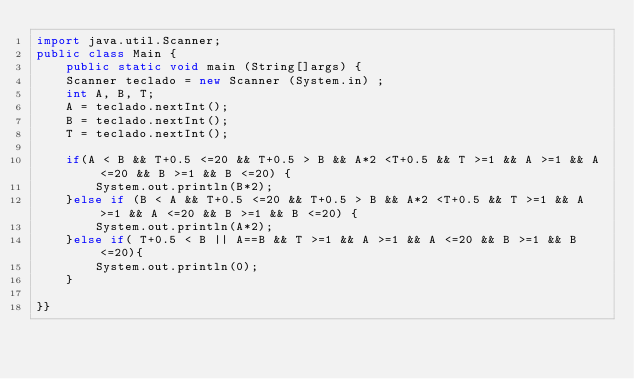Convert code to text. <code><loc_0><loc_0><loc_500><loc_500><_Java_>import java.util.Scanner;
public class Main {
	public static void main (String[]args) {
	Scanner teclado = new Scanner (System.in) ;		
	int A, B, T;
	A = teclado.nextInt();
	B = teclado.nextInt();
	T = teclado.nextInt();
	
	if(A < B && T+0.5 <=20 && T+0.5 > B && A*2 <T+0.5 && T >=1 && A >=1 && A <=20 && B >=1 && B <=20) {
		System.out.println(B*2);
	}else if (B < A && T+0.5 <=20 && T+0.5 > B && A*2 <T+0.5 && T >=1 && A >=1 && A <=20 && B >=1 && B <=20) {
		System.out.println(A*2);
	}else if( T+0.5 < B || A==B && T >=1 && A >=1 && A <=20 && B >=1 && B <=20){
		System.out.println(0);
	}
	
}}</code> 